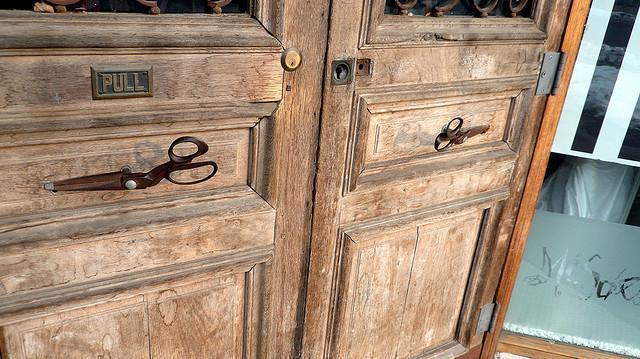How many people are wearing blue jeans?
Give a very brief answer. 0. 